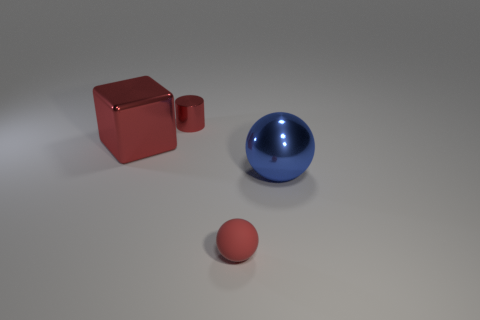Add 3 tiny purple metallic blocks. How many objects exist? 7 Subtract 1 spheres. How many spheres are left? 1 Add 4 large green rubber blocks. How many large green rubber blocks exist? 4 Subtract 0 gray blocks. How many objects are left? 4 Subtract all blocks. How many objects are left? 3 Subtract all blue balls. Subtract all brown cubes. How many balls are left? 1 Subtract all red balls. How many blue blocks are left? 0 Subtract all big yellow matte blocks. Subtract all red objects. How many objects are left? 1 Add 2 rubber things. How many rubber things are left? 3 